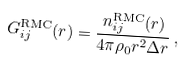Convert formula to latex. <formula><loc_0><loc_0><loc_500><loc_500>G ^ { \text {RMC} } _ { i j } ( r ) = \frac { n ^ { \text {RMC} } _ { i j } ( r ) } { 4 \pi \rho _ { 0 } r ^ { 2 } \Delta r } \, ,</formula> 